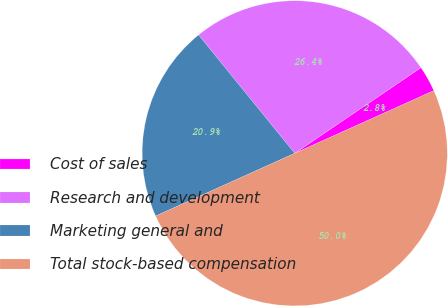<chart> <loc_0><loc_0><loc_500><loc_500><pie_chart><fcel>Cost of sales<fcel>Research and development<fcel>Marketing general and<fcel>Total stock-based compensation<nl><fcel>2.75%<fcel>26.37%<fcel>20.88%<fcel>50.0%<nl></chart> 